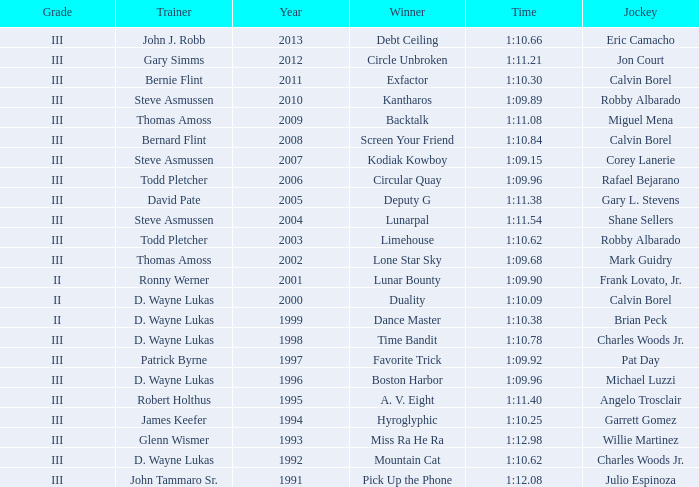Who won under Gary Simms? Circle Unbroken. Would you mind parsing the complete table? {'header': ['Grade', 'Trainer', 'Year', 'Winner', 'Time', 'Jockey'], 'rows': [['III', 'John J. Robb', '2013', 'Debt Ceiling', '1:10.66', 'Eric Camacho'], ['III', 'Gary Simms', '2012', 'Circle Unbroken', '1:11.21', 'Jon Court'], ['III', 'Bernie Flint', '2011', 'Exfactor', '1:10.30', 'Calvin Borel'], ['III', 'Steve Asmussen', '2010', 'Kantharos', '1:09.89', 'Robby Albarado'], ['III', 'Thomas Amoss', '2009', 'Backtalk', '1:11.08', 'Miguel Mena'], ['III', 'Bernard Flint', '2008', 'Screen Your Friend', '1:10.84', 'Calvin Borel'], ['III', 'Steve Asmussen', '2007', 'Kodiak Kowboy', '1:09.15', 'Corey Lanerie'], ['III', 'Todd Pletcher', '2006', 'Circular Quay', '1:09.96', 'Rafael Bejarano'], ['III', 'David Pate', '2005', 'Deputy G', '1:11.38', 'Gary L. Stevens'], ['III', 'Steve Asmussen', '2004', 'Lunarpal', '1:11.54', 'Shane Sellers'], ['III', 'Todd Pletcher', '2003', 'Limehouse', '1:10.62', 'Robby Albarado'], ['III', 'Thomas Amoss', '2002', 'Lone Star Sky', '1:09.68', 'Mark Guidry'], ['II', 'Ronny Werner', '2001', 'Lunar Bounty', '1:09.90', 'Frank Lovato, Jr.'], ['II', 'D. Wayne Lukas', '2000', 'Duality', '1:10.09', 'Calvin Borel'], ['II', 'D. Wayne Lukas', '1999', 'Dance Master', '1:10.38', 'Brian Peck'], ['III', 'D. Wayne Lukas', '1998', 'Time Bandit', '1:10.78', 'Charles Woods Jr.'], ['III', 'Patrick Byrne', '1997', 'Favorite Trick', '1:09.92', 'Pat Day'], ['III', 'D. Wayne Lukas', '1996', 'Boston Harbor', '1:09.96', 'Michael Luzzi'], ['III', 'Robert Holthus', '1995', 'A. V. Eight', '1:11.40', 'Angelo Trosclair'], ['III', 'James Keefer', '1994', 'Hyroglyphic', '1:10.25', 'Garrett Gomez'], ['III', 'Glenn Wismer', '1993', 'Miss Ra He Ra', '1:12.98', 'Willie Martinez'], ['III', 'D. Wayne Lukas', '1992', 'Mountain Cat', '1:10.62', 'Charles Woods Jr.'], ['III', 'John Tammaro Sr.', '1991', 'Pick Up the Phone', '1:12.08', 'Julio Espinoza']]} 